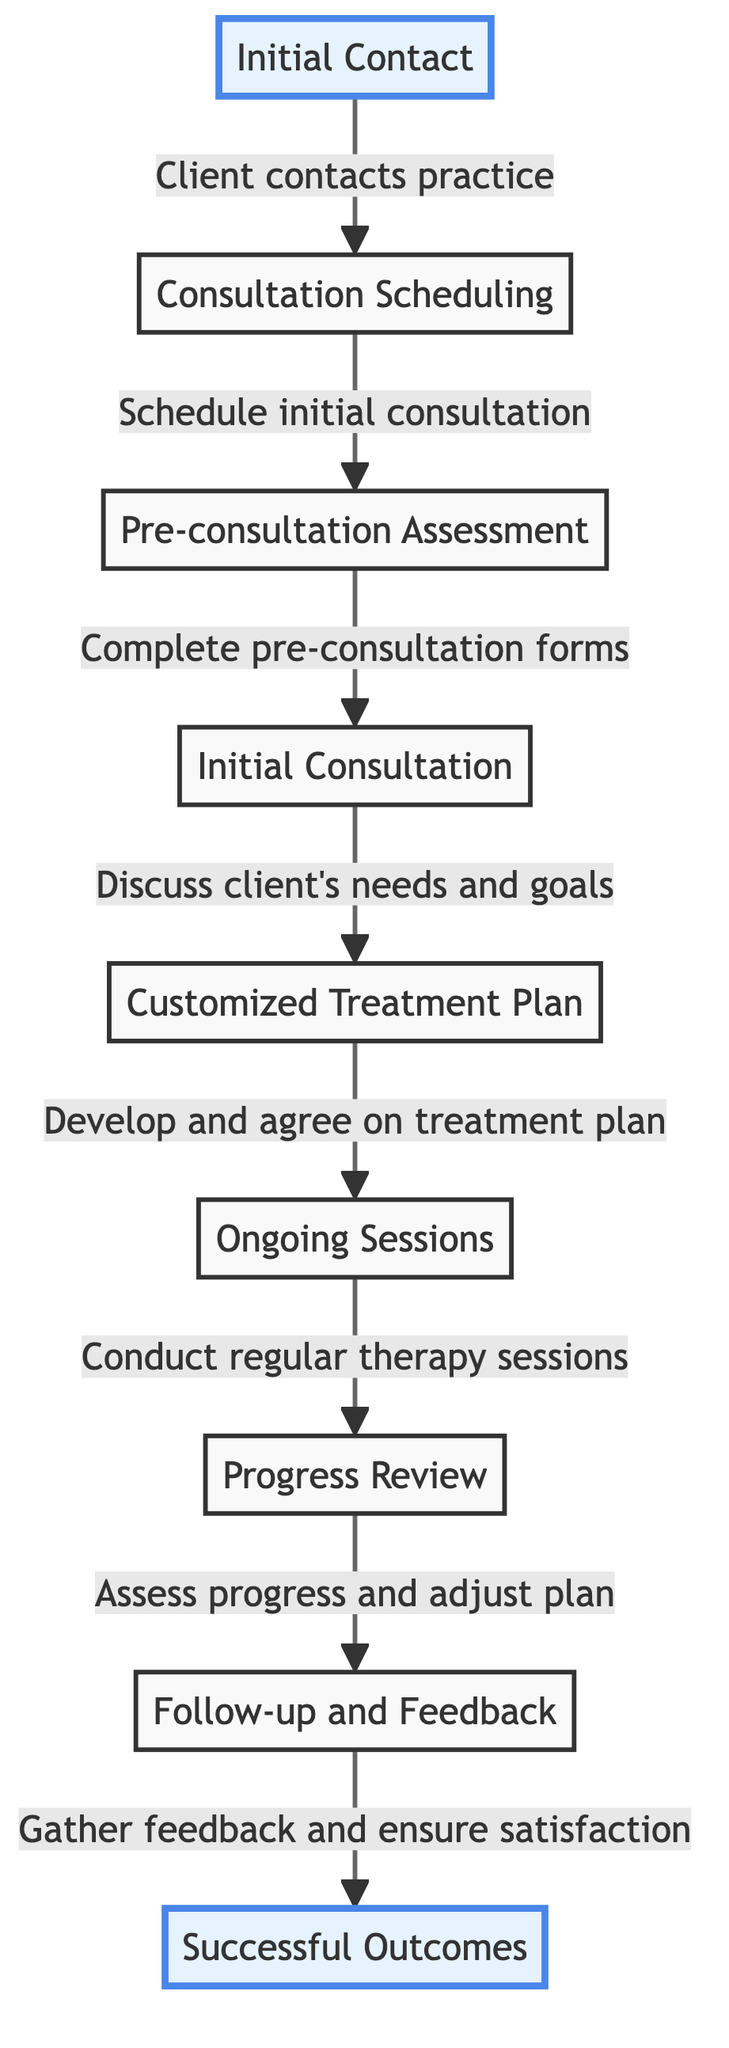What is the first step in the client journey? The first step in the diagram is clearly labeled as "Initial Contact," which is indicated as the starting point of the flow.
Answer: Initial Contact How many steps are there in total in the client journey map? By counting the nodes displayed in the diagram, we can see there are nine distinct steps in the client journey from initial contact to successful outcomes.
Answer: 9 What node follows the "Pre-consultation Assessment"? According to the directional arrows in the diagram, the node that comes after "Pre-consultation Assessment" is "Initial Consultation."
Answer: Initial Consultation What type of feedback is gathered in the last step? The diagram specifies that the last step involves gathering "feedback and ensure satisfaction," which indicates the nature of the feedback sought in this context.
Answer: Feedback and ensure satisfaction What is developed after the "Initial Consultation"? From the flow of the diagram, immediately following the "Initial Consultation," a "Customized Treatment Plan" is created as the next logical step.
Answer: Customized Treatment Plan What do ongoing sessions lead to? Following "Ongoing Sessions," the next step according to the diagram is "Progress Review," demonstrating the logical flow of the process.
Answer: Progress Review What node is the direct outcome of "Gather feedback and ensure satisfaction"? The node that directly follows "Gather feedback and ensure satisfaction" as indicated in the diagram is "Successful Outcomes," which concludes the journey.
Answer: Successful Outcomes Which two nodes are highlighted in the diagram? The diagram specifically highlights the "Initial Contact" and "Successful Outcomes" nodes, indicating their importance within the client journey.
Answer: Initial Contact, Successful Outcomes What action is taken after the "Consultation Scheduling"? According to the flow represented in the diagram, after "Consultation Scheduling," clients are expected to complete a "Pre-consultation Assessment."
Answer: Pre-consultation Assessment 